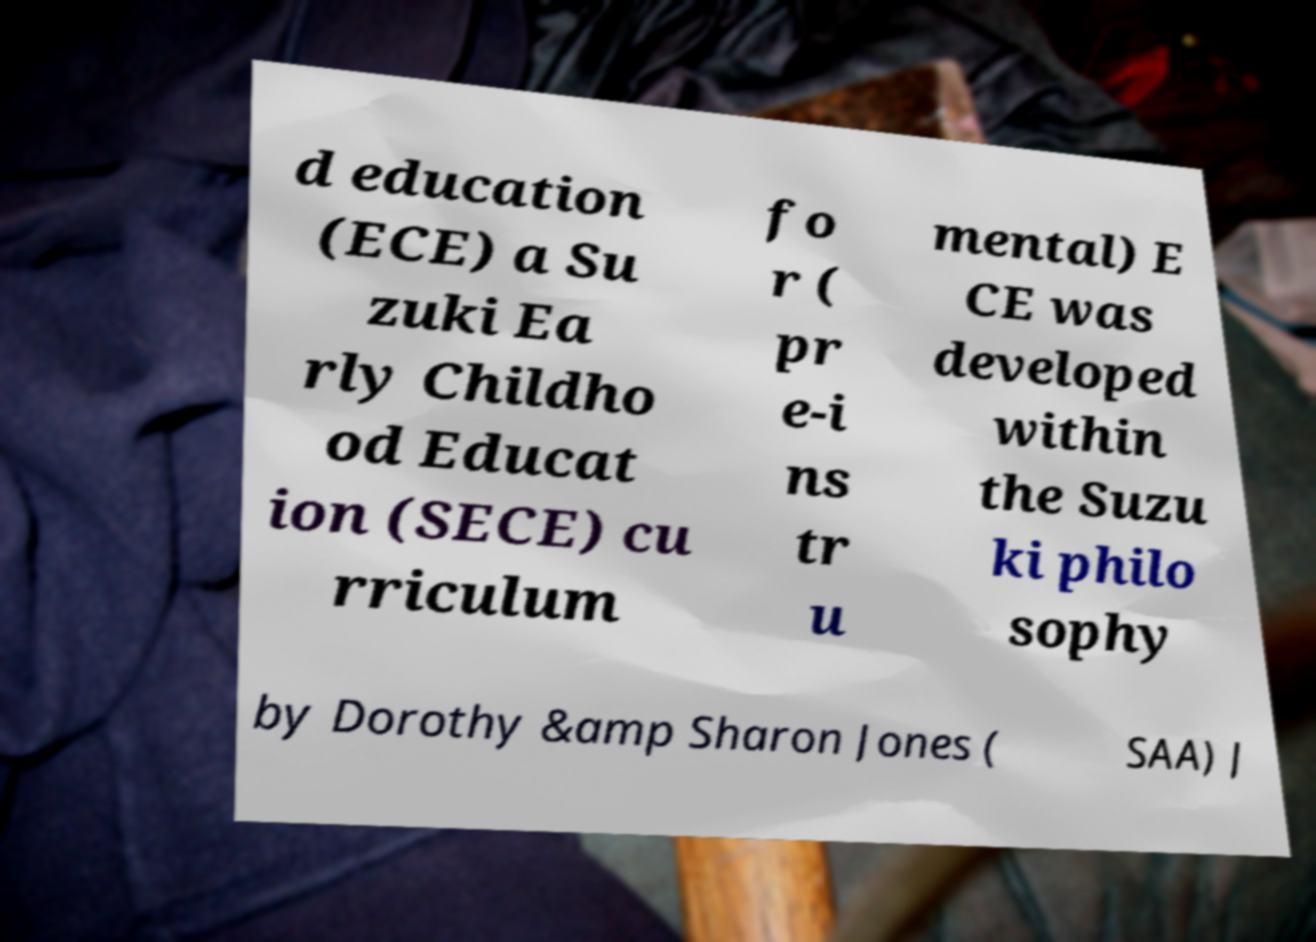Please read and relay the text visible in this image. What does it say? d education (ECE) a Su zuki Ea rly Childho od Educat ion (SECE) cu rriculum fo r ( pr e-i ns tr u mental) E CE was developed within the Suzu ki philo sophy by Dorothy &amp Sharon Jones ( SAA) J 